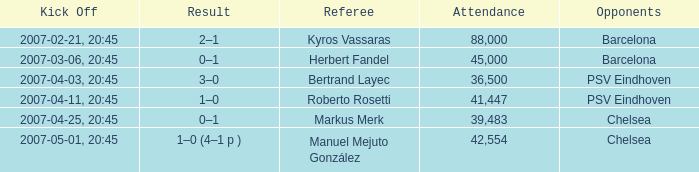WHAT OPPONENT HAD A KICKOFF OF 2007-03-06, 20:45? Barcelona. 